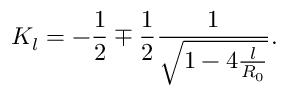Convert formula to latex. <formula><loc_0><loc_0><loc_500><loc_500>K _ { l } = - \frac { 1 } { 2 } \mp \frac { 1 } { 2 } \frac { 1 } { \sqrt { 1 - 4 \frac { l } { R _ { 0 } } } } .</formula> 